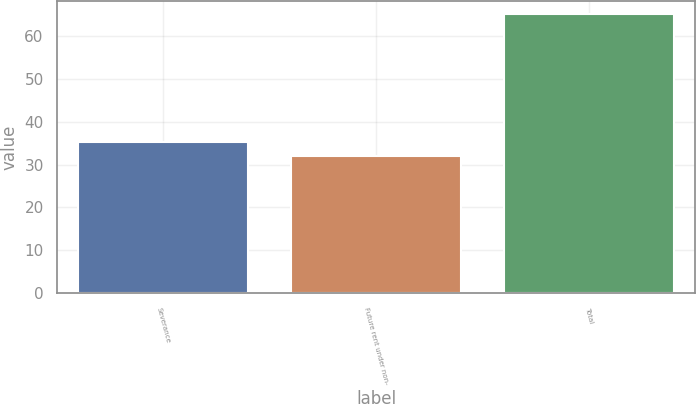<chart> <loc_0><loc_0><loc_500><loc_500><bar_chart><fcel>Severance<fcel>Future rent under non-<fcel>Total<nl><fcel>35.3<fcel>32<fcel>65<nl></chart> 